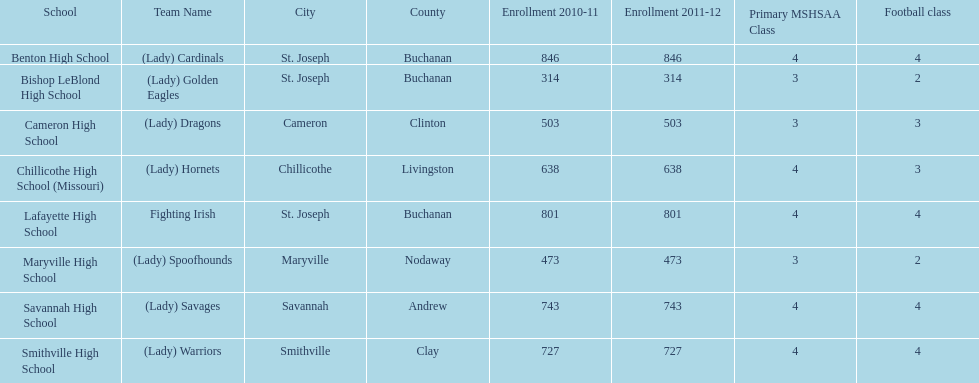I'm looking to parse the entire table for insights. Could you assist me with that? {'header': ['School', 'Team Name', 'City', 'County', 'Enrollment 2010-11', 'Enrollment 2011-12', 'Primary MSHSAA Class', 'Football class'], 'rows': [['Benton High School', '(Lady) Cardinals', 'St. Joseph', 'Buchanan', '846', '846', '4', '4'], ['Bishop LeBlond High School', '(Lady) Golden Eagles', 'St. Joseph', 'Buchanan', '314', '314', '3', '2'], ['Cameron High School', '(Lady) Dragons', 'Cameron', 'Clinton', '503', '503', '3', '3'], ['Chillicothe High School (Missouri)', '(Lady) Hornets', 'Chillicothe', 'Livingston', '638', '638', '4', '3'], ['Lafayette High School', 'Fighting Irish', 'St. Joseph', 'Buchanan', '801', '801', '4', '4'], ['Maryville High School', '(Lady) Spoofhounds', 'Maryville', 'Nodaway', '473', '473', '3', '2'], ['Savannah High School', '(Lady) Savages', 'Savannah', 'Andrew', '743', '743', '4', '4'], ['Smithville High School', '(Lady) Warriors', 'Smithville', 'Clay', '727', '727', '4', '4']]} What is the number of football classes lafayette high school has? 4. 